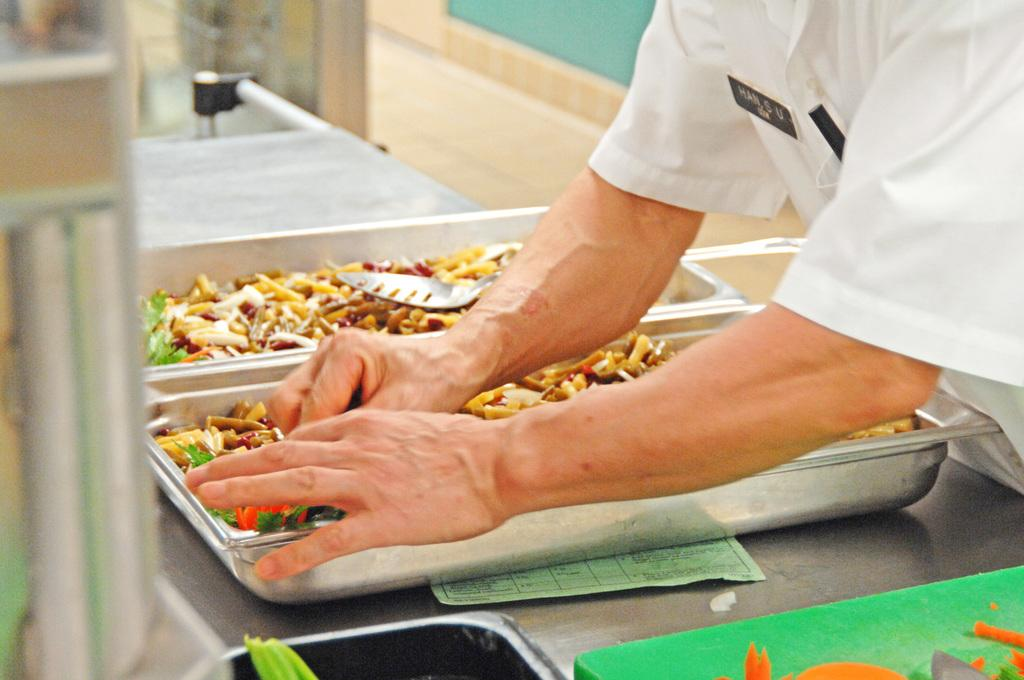What can be seen on the trays in the image? There are two trays with food in the image. Who is present in the image besides the food? A man is standing beside the trays. What is the man doing in the image? The man is doing something with the food. What type of pies can be seen on the trays in the image? There is no mention of pies in the image; it only states that there are two trays with food. 